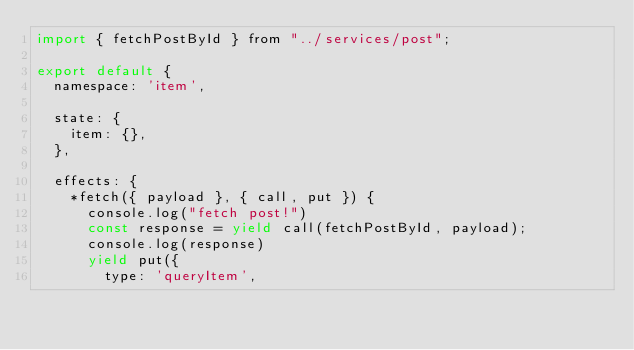Convert code to text. <code><loc_0><loc_0><loc_500><loc_500><_JavaScript_>import { fetchPostById } from "../services/post";

export default {
  namespace: 'item',

  state: {
    item: {},
  },

  effects: {
    *fetch({ payload }, { call, put }) {
      console.log("fetch post!")
      const response = yield call(fetchPostById, payload);
      console.log(response)
      yield put({
        type: 'queryItem',</code> 